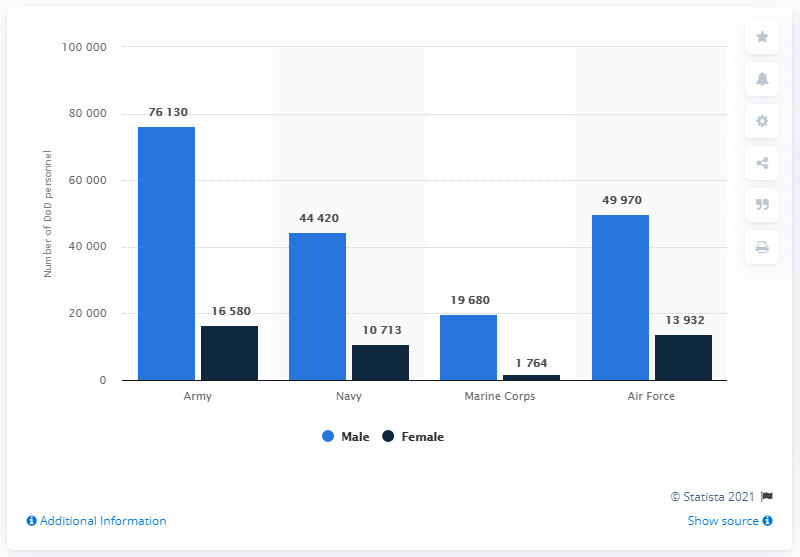Identify some key points in this picture. The text states that the Male data is 49970 and the female data is 13932, and both of these values belong to the category of Air Force. The total number of Air Force personnel is 63,902, including both males and females. 